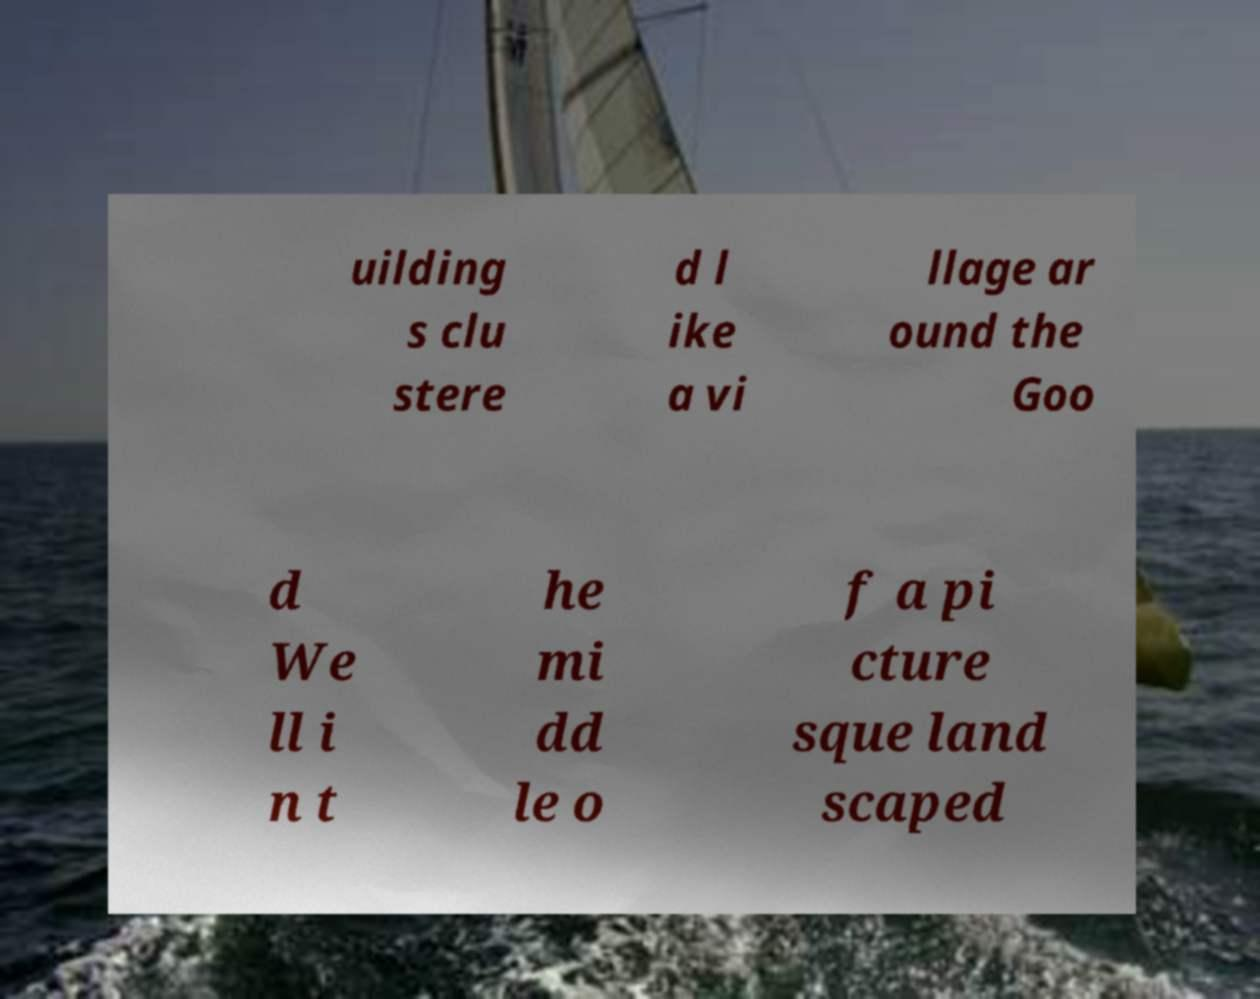For documentation purposes, I need the text within this image transcribed. Could you provide that? uilding s clu stere d l ike a vi llage ar ound the Goo d We ll i n t he mi dd le o f a pi cture sque land scaped 